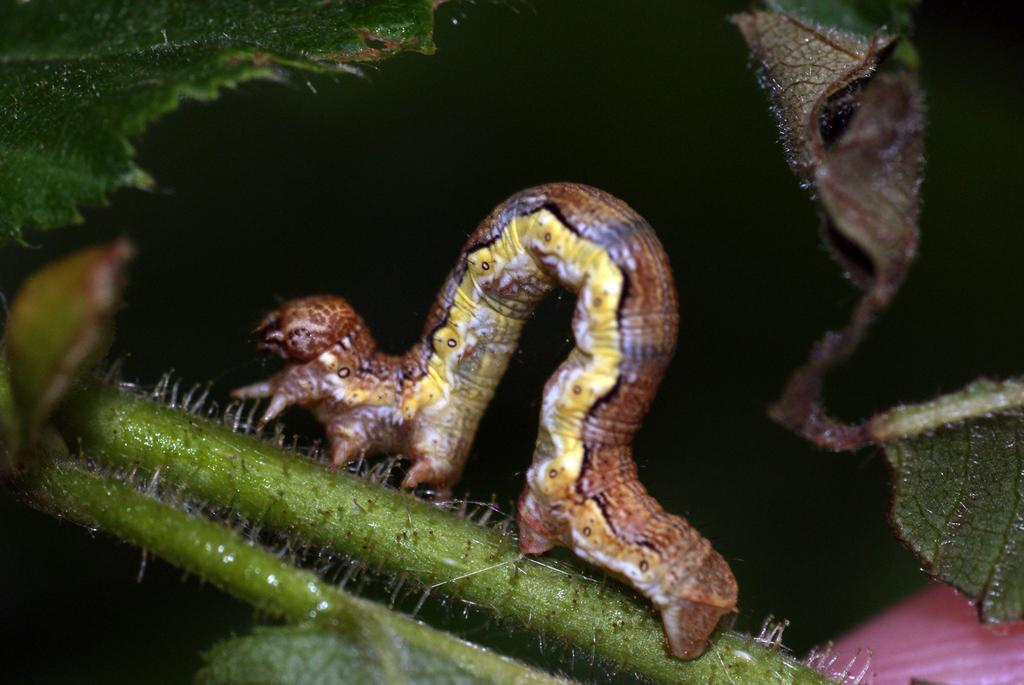What type of insect is in the image? There is a yellow and brown insect in the image. What is the insect doing in the image? The insect is crawling on a plant stem. What can be seen in the background of the image? The background of the image is blurred. What type of vegetation is present in the image? There are green leaves visible in the image. What type of chin can be seen on the insect in the image? There is no chin present on the insect in the image, as insects do not have chins. How many beads are visible on the plant stem in the image? There are no beads present on the plant stem in the image; only the insect and green leaves are visible. 